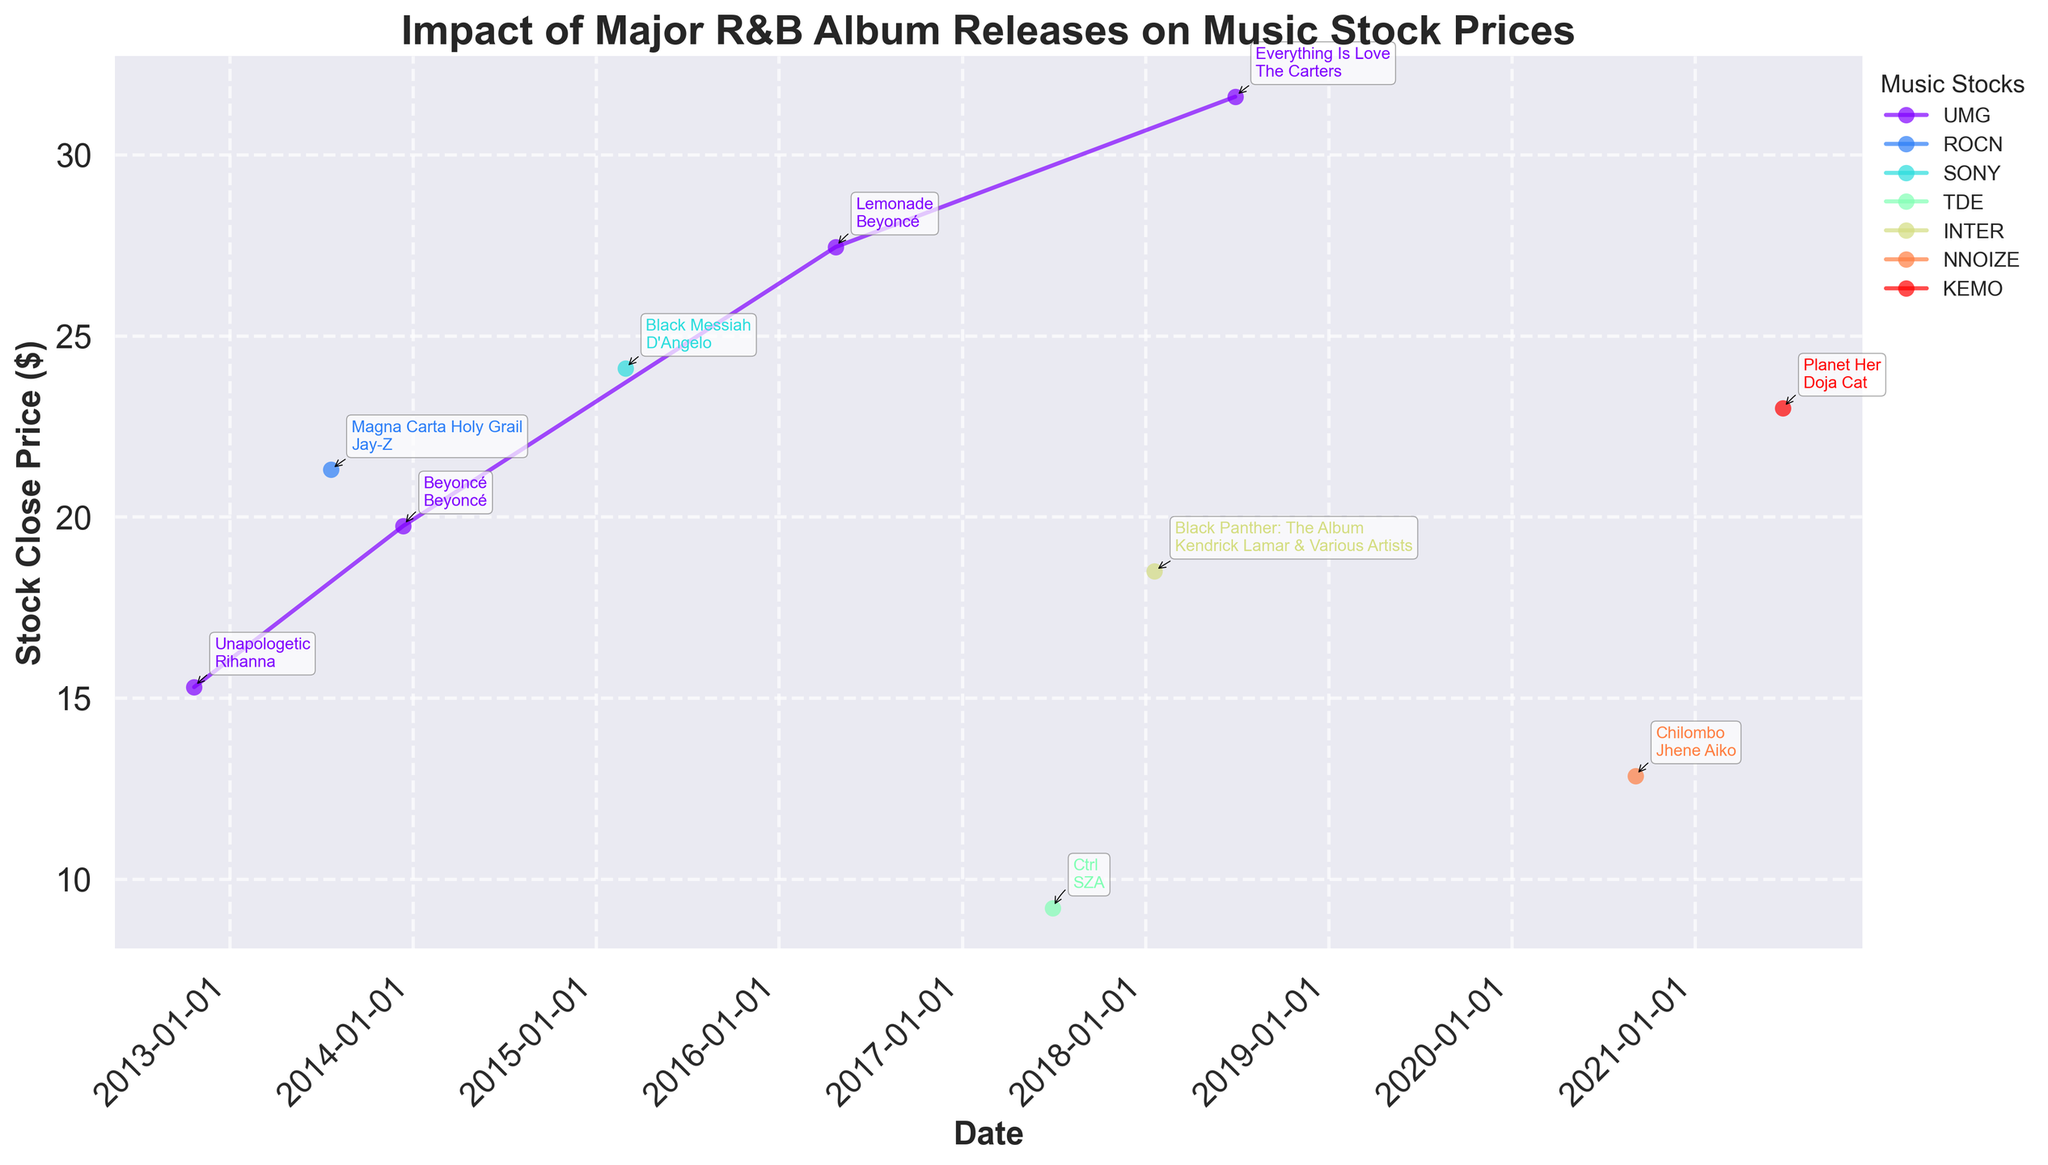What is the title of the plot? The title is written at the top of the plot and usually provides a summary of what the plot represents. In this case, it is about the impact of major R&B album releases on music stock prices over the past decade.
Answer: Impact of Major R&B Album Releases on Music Stock Prices How many different music stock tickers are represented in the plot? By looking at the legend on the right side of the plot, we can count the unique tickers used. These are typically color-coded for differentiation.
Answer: Six Which album release occurred on the earliest date in the dataset? Check the x-axis for the earliest date and find which album release annotation corresponds to it.
Answer: Unapologetic by Rihanna What is the highest stock close price after any album release? Locate the highest point on the y-axis and find the closest annotation mark to identify the stock close price.
Answer: $31.60 How much did Universal Music Group's stock close price increase following the release of Beyoncé's "Lemonade"? Look for the "Lemonade" annotation on Universal Music Group's line in the plot and find the corresponding stock close price before and after the release to calculate the difference.
Answer: $1.78 Which artist's album release resulted in the largest stock price increase on the same or following day? Identify which album release annotation has the greatest difference between the stock open and close prices on the plot.
Answer: Beyoncé with "Lemonade" On which date did Top Dawg Entertainment's stock have a significant close price, and which album was released on that date? Trace the date with the closest point on Top Dawg Entertainment's line with a notable stock close price and find the corresponding album annotation.
Answer: June 30, 2017, "Ctrl" by SZA What is the trend in Universal Music Group's stock prices with respect to the different album releases marked on the plot? Follow the peaks and valleys along Universal Music Group's line in the plot and observe the annotated album releases to describe the general trend.
Answer: Generally increasing How did Sony Music Entertainment's stock close price react to the release of D'Angelo's "Black Messiah" compared to its previous close price? Find D'Angelo's "Black Messiah" annotation on Sony Music Entertainment's line and compare the stock close price before and after the release.
Answer: $0.65 increase Which album releases are represented by Universal Music Group, and did each release result in a stock price increase or decrease? Identify each album annotated under Universal Music Group's line and compare the stock close prices before and after each release.
Answer: Beyoncé's "Beyoncé" (increase), Beyoncé's "Lemonade" (increase), The Carters' "Everything Is Love" (increase), Rihanna's "Unapologetic" (increase) 